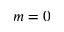Convert formula to latex. <formula><loc_0><loc_0><loc_500><loc_500>m = 0</formula> 